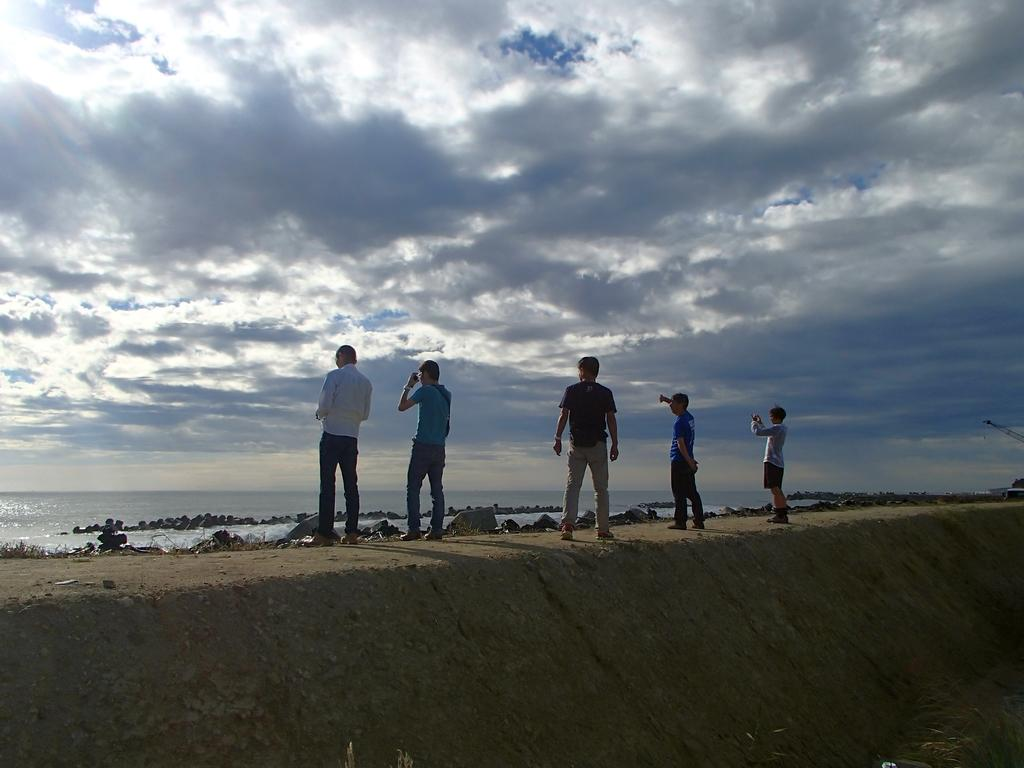How many people are present in the image? There are five people standing in the image. What type of terrain is visible in the image? There is soil and rocks visible in the image. What can be seen in the background of the image? There is an ocean in the backdrop of the image. What is the condition of the sky in the image? The sky is clear in the image. What type of branch can be seen in the hands of the deer in the image? There is no deer or branch present in the image. What letters are visible on the rocks in the image? There are no letters visible on the rocks in the image. 